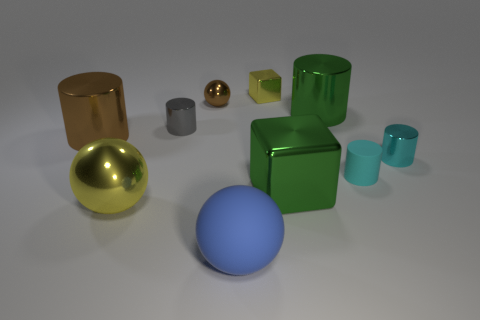What number of metal objects are both in front of the tiny sphere and behind the large yellow sphere?
Ensure brevity in your answer.  5. Is the number of brown balls that are to the right of the cyan matte object less than the number of blue metal things?
Offer a very short reply. No. Are there any gray objects that have the same size as the cyan shiny cylinder?
Offer a very short reply. Yes. There is a big ball that is the same material as the small gray object; what color is it?
Your answer should be compact. Yellow. There is a matte ball that is to the right of the small brown thing; how many small gray metal cylinders are to the right of it?
Provide a succinct answer. 0. The cylinder that is in front of the gray shiny cylinder and left of the small brown object is made of what material?
Give a very brief answer. Metal. There is a green metal thing that is on the right side of the green block; does it have the same shape as the large blue rubber thing?
Offer a terse response. No. Are there fewer big brown objects than big green metal balls?
Ensure brevity in your answer.  No. What number of metal spheres have the same color as the big metal block?
Keep it short and to the point. 0. There is a sphere that is the same color as the tiny cube; what is its material?
Keep it short and to the point. Metal. 